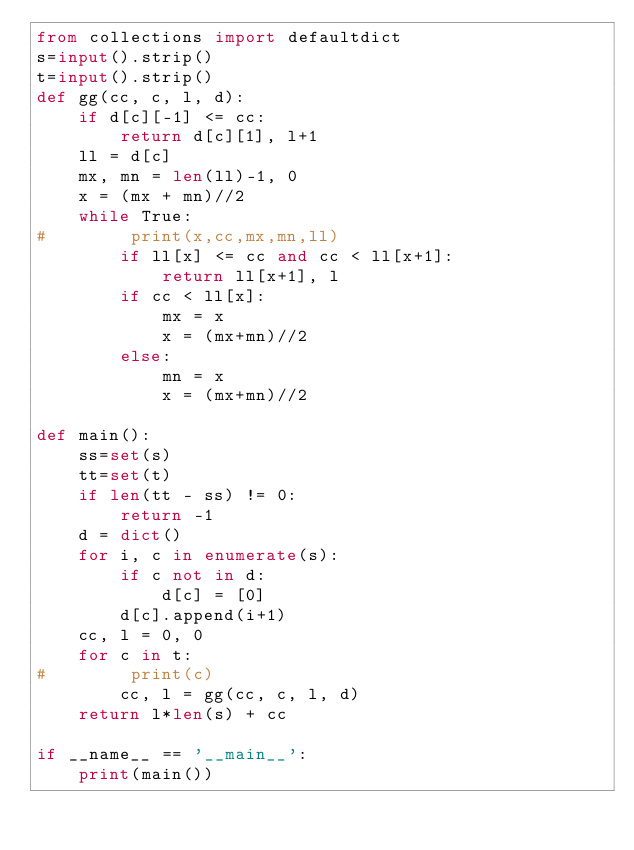<code> <loc_0><loc_0><loc_500><loc_500><_Python_>from collections import defaultdict
s=input().strip()
t=input().strip()
def gg(cc, c, l, d):
    if d[c][-1] <= cc:
        return d[c][1], l+1
    ll = d[c]
    mx, mn = len(ll)-1, 0
    x = (mx + mn)//2
    while True:
#        print(x,cc,mx,mn,ll)
        if ll[x] <= cc and cc < ll[x+1]:
            return ll[x+1], l
        if cc < ll[x]:
            mx = x
            x = (mx+mn)//2
        else:
            mn = x
            x = (mx+mn)//2

def main():
    ss=set(s)
    tt=set(t)
    if len(tt - ss) != 0: 
        return -1
    d = dict()
    for i, c in enumerate(s):
        if c not in d:
            d[c] = [0]
        d[c].append(i+1)
    cc, l = 0, 0
    for c in t:
#        print(c)
        cc, l = gg(cc, c, l, d)
    return l*len(s) + cc

if __name__ == '__main__':
    print(main())

</code> 